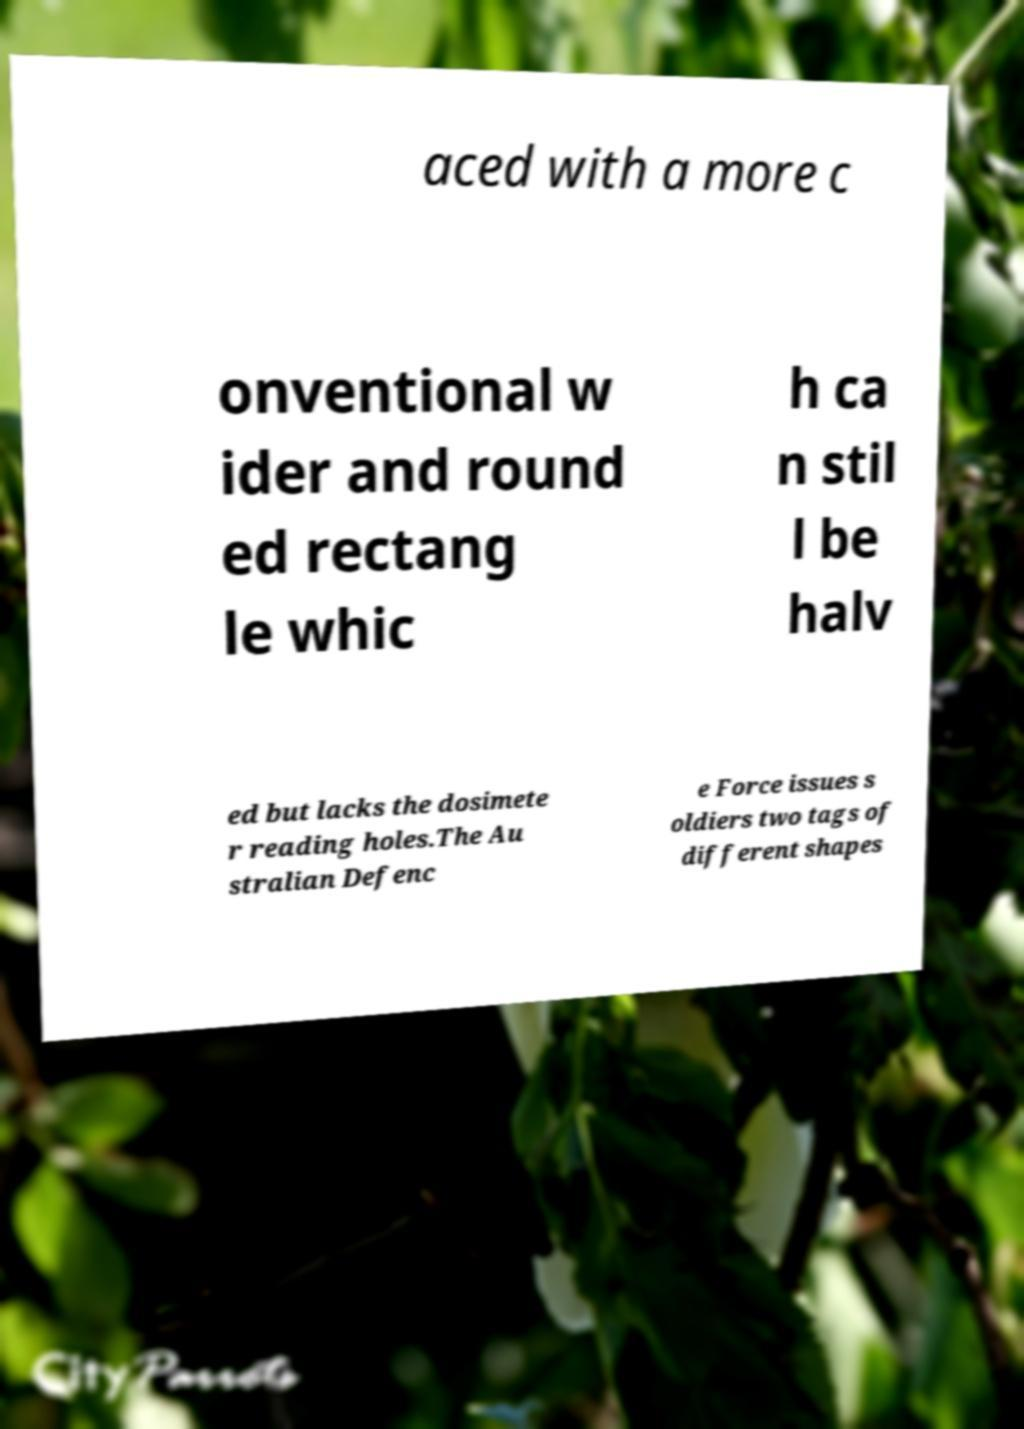There's text embedded in this image that I need extracted. Can you transcribe it verbatim? aced with a more c onventional w ider and round ed rectang le whic h ca n stil l be halv ed but lacks the dosimete r reading holes.The Au stralian Defenc e Force issues s oldiers two tags of different shapes 